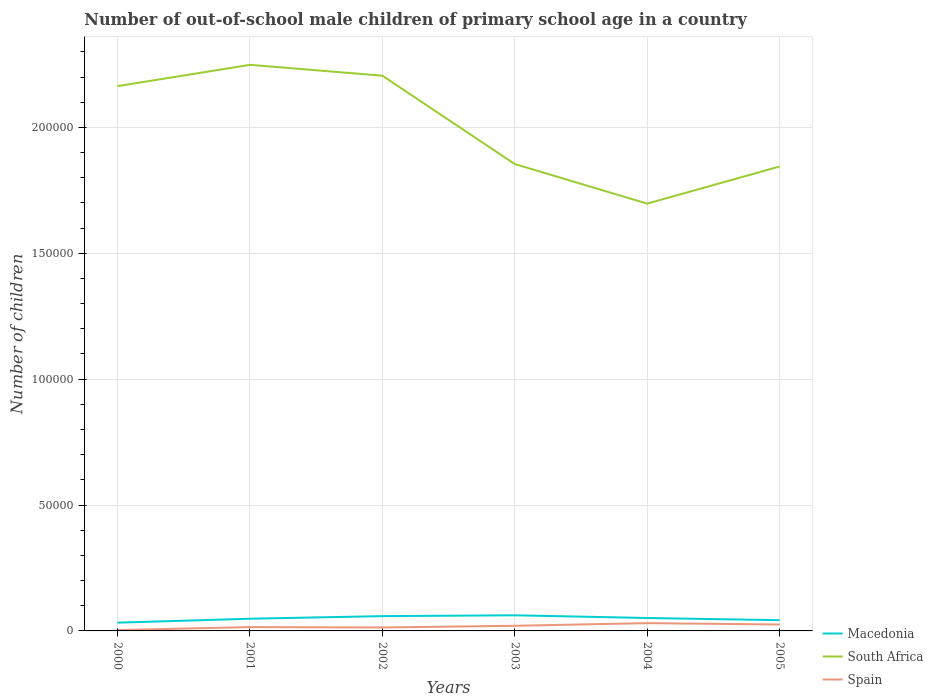Is the number of lines equal to the number of legend labels?
Your answer should be compact. Yes. Across all years, what is the maximum number of out-of-school male children in Spain?
Make the answer very short. 344. In which year was the number of out-of-school male children in Macedonia maximum?
Give a very brief answer. 2000. What is the total number of out-of-school male children in South Africa in the graph?
Give a very brief answer. 3.19e+04. What is the difference between the highest and the second highest number of out-of-school male children in Spain?
Give a very brief answer. 2748. What is the difference between the highest and the lowest number of out-of-school male children in South Africa?
Give a very brief answer. 3. Is the number of out-of-school male children in Macedonia strictly greater than the number of out-of-school male children in Spain over the years?
Give a very brief answer. No. What is the difference between two consecutive major ticks on the Y-axis?
Make the answer very short. 5.00e+04. Does the graph contain grids?
Give a very brief answer. Yes. How many legend labels are there?
Your answer should be compact. 3. How are the legend labels stacked?
Your answer should be very brief. Vertical. What is the title of the graph?
Offer a terse response. Number of out-of-school male children of primary school age in a country. What is the label or title of the Y-axis?
Provide a succinct answer. Number of children. What is the Number of children of Macedonia in 2000?
Keep it short and to the point. 3274. What is the Number of children of South Africa in 2000?
Keep it short and to the point. 2.16e+05. What is the Number of children of Spain in 2000?
Make the answer very short. 344. What is the Number of children in Macedonia in 2001?
Ensure brevity in your answer.  4844. What is the Number of children of South Africa in 2001?
Give a very brief answer. 2.25e+05. What is the Number of children of Spain in 2001?
Make the answer very short. 1514. What is the Number of children of Macedonia in 2002?
Give a very brief answer. 5878. What is the Number of children of South Africa in 2002?
Your answer should be compact. 2.21e+05. What is the Number of children in Spain in 2002?
Provide a short and direct response. 1368. What is the Number of children in Macedonia in 2003?
Keep it short and to the point. 6208. What is the Number of children of South Africa in 2003?
Offer a terse response. 1.85e+05. What is the Number of children in Spain in 2003?
Your response must be concise. 2044. What is the Number of children of Macedonia in 2004?
Offer a very short reply. 5133. What is the Number of children of South Africa in 2004?
Offer a very short reply. 1.70e+05. What is the Number of children of Spain in 2004?
Offer a very short reply. 3092. What is the Number of children in Macedonia in 2005?
Offer a terse response. 4262. What is the Number of children of South Africa in 2005?
Provide a succinct answer. 1.84e+05. What is the Number of children of Spain in 2005?
Your answer should be very brief. 2551. Across all years, what is the maximum Number of children of Macedonia?
Your answer should be very brief. 6208. Across all years, what is the maximum Number of children of South Africa?
Ensure brevity in your answer.  2.25e+05. Across all years, what is the maximum Number of children of Spain?
Provide a succinct answer. 3092. Across all years, what is the minimum Number of children of Macedonia?
Offer a very short reply. 3274. Across all years, what is the minimum Number of children in South Africa?
Provide a short and direct response. 1.70e+05. Across all years, what is the minimum Number of children in Spain?
Ensure brevity in your answer.  344. What is the total Number of children of Macedonia in the graph?
Provide a succinct answer. 2.96e+04. What is the total Number of children in South Africa in the graph?
Make the answer very short. 1.20e+06. What is the total Number of children of Spain in the graph?
Give a very brief answer. 1.09e+04. What is the difference between the Number of children in Macedonia in 2000 and that in 2001?
Offer a very short reply. -1570. What is the difference between the Number of children of South Africa in 2000 and that in 2001?
Ensure brevity in your answer.  -8460. What is the difference between the Number of children of Spain in 2000 and that in 2001?
Keep it short and to the point. -1170. What is the difference between the Number of children in Macedonia in 2000 and that in 2002?
Offer a terse response. -2604. What is the difference between the Number of children of South Africa in 2000 and that in 2002?
Provide a succinct answer. -4153. What is the difference between the Number of children in Spain in 2000 and that in 2002?
Your response must be concise. -1024. What is the difference between the Number of children of Macedonia in 2000 and that in 2003?
Ensure brevity in your answer.  -2934. What is the difference between the Number of children in South Africa in 2000 and that in 2003?
Offer a terse response. 3.09e+04. What is the difference between the Number of children in Spain in 2000 and that in 2003?
Offer a terse response. -1700. What is the difference between the Number of children of Macedonia in 2000 and that in 2004?
Provide a short and direct response. -1859. What is the difference between the Number of children of South Africa in 2000 and that in 2004?
Provide a succinct answer. 4.67e+04. What is the difference between the Number of children in Spain in 2000 and that in 2004?
Your answer should be compact. -2748. What is the difference between the Number of children of Macedonia in 2000 and that in 2005?
Make the answer very short. -988. What is the difference between the Number of children in South Africa in 2000 and that in 2005?
Keep it short and to the point. 3.19e+04. What is the difference between the Number of children of Spain in 2000 and that in 2005?
Your response must be concise. -2207. What is the difference between the Number of children of Macedonia in 2001 and that in 2002?
Your answer should be compact. -1034. What is the difference between the Number of children of South Africa in 2001 and that in 2002?
Give a very brief answer. 4307. What is the difference between the Number of children of Spain in 2001 and that in 2002?
Provide a short and direct response. 146. What is the difference between the Number of children of Macedonia in 2001 and that in 2003?
Keep it short and to the point. -1364. What is the difference between the Number of children in South Africa in 2001 and that in 2003?
Offer a terse response. 3.94e+04. What is the difference between the Number of children of Spain in 2001 and that in 2003?
Your answer should be very brief. -530. What is the difference between the Number of children of Macedonia in 2001 and that in 2004?
Offer a very short reply. -289. What is the difference between the Number of children in South Africa in 2001 and that in 2004?
Offer a very short reply. 5.51e+04. What is the difference between the Number of children in Spain in 2001 and that in 2004?
Offer a very short reply. -1578. What is the difference between the Number of children in Macedonia in 2001 and that in 2005?
Ensure brevity in your answer.  582. What is the difference between the Number of children in South Africa in 2001 and that in 2005?
Ensure brevity in your answer.  4.04e+04. What is the difference between the Number of children in Spain in 2001 and that in 2005?
Your answer should be very brief. -1037. What is the difference between the Number of children in Macedonia in 2002 and that in 2003?
Your answer should be very brief. -330. What is the difference between the Number of children in South Africa in 2002 and that in 2003?
Provide a succinct answer. 3.51e+04. What is the difference between the Number of children of Spain in 2002 and that in 2003?
Provide a succinct answer. -676. What is the difference between the Number of children of Macedonia in 2002 and that in 2004?
Give a very brief answer. 745. What is the difference between the Number of children in South Africa in 2002 and that in 2004?
Offer a very short reply. 5.08e+04. What is the difference between the Number of children in Spain in 2002 and that in 2004?
Your response must be concise. -1724. What is the difference between the Number of children of Macedonia in 2002 and that in 2005?
Provide a succinct answer. 1616. What is the difference between the Number of children in South Africa in 2002 and that in 2005?
Provide a short and direct response. 3.61e+04. What is the difference between the Number of children of Spain in 2002 and that in 2005?
Keep it short and to the point. -1183. What is the difference between the Number of children in Macedonia in 2003 and that in 2004?
Provide a short and direct response. 1075. What is the difference between the Number of children of South Africa in 2003 and that in 2004?
Your answer should be compact. 1.57e+04. What is the difference between the Number of children in Spain in 2003 and that in 2004?
Your answer should be compact. -1048. What is the difference between the Number of children in Macedonia in 2003 and that in 2005?
Provide a short and direct response. 1946. What is the difference between the Number of children in South Africa in 2003 and that in 2005?
Ensure brevity in your answer.  980. What is the difference between the Number of children of Spain in 2003 and that in 2005?
Keep it short and to the point. -507. What is the difference between the Number of children in Macedonia in 2004 and that in 2005?
Keep it short and to the point. 871. What is the difference between the Number of children in South Africa in 2004 and that in 2005?
Offer a very short reply. -1.47e+04. What is the difference between the Number of children of Spain in 2004 and that in 2005?
Make the answer very short. 541. What is the difference between the Number of children of Macedonia in 2000 and the Number of children of South Africa in 2001?
Offer a terse response. -2.22e+05. What is the difference between the Number of children of Macedonia in 2000 and the Number of children of Spain in 2001?
Provide a succinct answer. 1760. What is the difference between the Number of children in South Africa in 2000 and the Number of children in Spain in 2001?
Make the answer very short. 2.15e+05. What is the difference between the Number of children of Macedonia in 2000 and the Number of children of South Africa in 2002?
Your answer should be compact. -2.17e+05. What is the difference between the Number of children in Macedonia in 2000 and the Number of children in Spain in 2002?
Your response must be concise. 1906. What is the difference between the Number of children of South Africa in 2000 and the Number of children of Spain in 2002?
Provide a succinct answer. 2.15e+05. What is the difference between the Number of children in Macedonia in 2000 and the Number of children in South Africa in 2003?
Offer a terse response. -1.82e+05. What is the difference between the Number of children in Macedonia in 2000 and the Number of children in Spain in 2003?
Your response must be concise. 1230. What is the difference between the Number of children of South Africa in 2000 and the Number of children of Spain in 2003?
Offer a very short reply. 2.14e+05. What is the difference between the Number of children in Macedonia in 2000 and the Number of children in South Africa in 2004?
Give a very brief answer. -1.66e+05. What is the difference between the Number of children of Macedonia in 2000 and the Number of children of Spain in 2004?
Provide a succinct answer. 182. What is the difference between the Number of children in South Africa in 2000 and the Number of children in Spain in 2004?
Offer a terse response. 2.13e+05. What is the difference between the Number of children in Macedonia in 2000 and the Number of children in South Africa in 2005?
Make the answer very short. -1.81e+05. What is the difference between the Number of children in Macedonia in 2000 and the Number of children in Spain in 2005?
Offer a very short reply. 723. What is the difference between the Number of children in South Africa in 2000 and the Number of children in Spain in 2005?
Keep it short and to the point. 2.14e+05. What is the difference between the Number of children in Macedonia in 2001 and the Number of children in South Africa in 2002?
Give a very brief answer. -2.16e+05. What is the difference between the Number of children of Macedonia in 2001 and the Number of children of Spain in 2002?
Give a very brief answer. 3476. What is the difference between the Number of children of South Africa in 2001 and the Number of children of Spain in 2002?
Give a very brief answer. 2.23e+05. What is the difference between the Number of children in Macedonia in 2001 and the Number of children in South Africa in 2003?
Your answer should be compact. -1.81e+05. What is the difference between the Number of children in Macedonia in 2001 and the Number of children in Spain in 2003?
Your answer should be very brief. 2800. What is the difference between the Number of children of South Africa in 2001 and the Number of children of Spain in 2003?
Ensure brevity in your answer.  2.23e+05. What is the difference between the Number of children of Macedonia in 2001 and the Number of children of South Africa in 2004?
Your answer should be compact. -1.65e+05. What is the difference between the Number of children of Macedonia in 2001 and the Number of children of Spain in 2004?
Your answer should be compact. 1752. What is the difference between the Number of children in South Africa in 2001 and the Number of children in Spain in 2004?
Offer a terse response. 2.22e+05. What is the difference between the Number of children of Macedonia in 2001 and the Number of children of South Africa in 2005?
Make the answer very short. -1.80e+05. What is the difference between the Number of children of Macedonia in 2001 and the Number of children of Spain in 2005?
Offer a terse response. 2293. What is the difference between the Number of children of South Africa in 2001 and the Number of children of Spain in 2005?
Give a very brief answer. 2.22e+05. What is the difference between the Number of children in Macedonia in 2002 and the Number of children in South Africa in 2003?
Offer a terse response. -1.80e+05. What is the difference between the Number of children in Macedonia in 2002 and the Number of children in Spain in 2003?
Keep it short and to the point. 3834. What is the difference between the Number of children in South Africa in 2002 and the Number of children in Spain in 2003?
Make the answer very short. 2.19e+05. What is the difference between the Number of children in Macedonia in 2002 and the Number of children in South Africa in 2004?
Offer a very short reply. -1.64e+05. What is the difference between the Number of children of Macedonia in 2002 and the Number of children of Spain in 2004?
Offer a terse response. 2786. What is the difference between the Number of children of South Africa in 2002 and the Number of children of Spain in 2004?
Offer a very short reply. 2.17e+05. What is the difference between the Number of children of Macedonia in 2002 and the Number of children of South Africa in 2005?
Your answer should be compact. -1.79e+05. What is the difference between the Number of children in Macedonia in 2002 and the Number of children in Spain in 2005?
Offer a very short reply. 3327. What is the difference between the Number of children in South Africa in 2002 and the Number of children in Spain in 2005?
Provide a succinct answer. 2.18e+05. What is the difference between the Number of children of Macedonia in 2003 and the Number of children of South Africa in 2004?
Make the answer very short. -1.64e+05. What is the difference between the Number of children of Macedonia in 2003 and the Number of children of Spain in 2004?
Give a very brief answer. 3116. What is the difference between the Number of children of South Africa in 2003 and the Number of children of Spain in 2004?
Keep it short and to the point. 1.82e+05. What is the difference between the Number of children of Macedonia in 2003 and the Number of children of South Africa in 2005?
Provide a succinct answer. -1.78e+05. What is the difference between the Number of children in Macedonia in 2003 and the Number of children in Spain in 2005?
Your response must be concise. 3657. What is the difference between the Number of children of South Africa in 2003 and the Number of children of Spain in 2005?
Your response must be concise. 1.83e+05. What is the difference between the Number of children of Macedonia in 2004 and the Number of children of South Africa in 2005?
Offer a terse response. -1.79e+05. What is the difference between the Number of children of Macedonia in 2004 and the Number of children of Spain in 2005?
Provide a succinct answer. 2582. What is the difference between the Number of children of South Africa in 2004 and the Number of children of Spain in 2005?
Keep it short and to the point. 1.67e+05. What is the average Number of children of Macedonia per year?
Your answer should be very brief. 4933.17. What is the average Number of children in South Africa per year?
Your answer should be compact. 2.00e+05. What is the average Number of children in Spain per year?
Provide a short and direct response. 1818.83. In the year 2000, what is the difference between the Number of children in Macedonia and Number of children in South Africa?
Offer a terse response. -2.13e+05. In the year 2000, what is the difference between the Number of children of Macedonia and Number of children of Spain?
Offer a very short reply. 2930. In the year 2000, what is the difference between the Number of children of South Africa and Number of children of Spain?
Provide a short and direct response. 2.16e+05. In the year 2001, what is the difference between the Number of children in Macedonia and Number of children in South Africa?
Offer a very short reply. -2.20e+05. In the year 2001, what is the difference between the Number of children in Macedonia and Number of children in Spain?
Make the answer very short. 3330. In the year 2001, what is the difference between the Number of children in South Africa and Number of children in Spain?
Provide a short and direct response. 2.23e+05. In the year 2002, what is the difference between the Number of children in Macedonia and Number of children in South Africa?
Your answer should be compact. -2.15e+05. In the year 2002, what is the difference between the Number of children of Macedonia and Number of children of Spain?
Keep it short and to the point. 4510. In the year 2002, what is the difference between the Number of children of South Africa and Number of children of Spain?
Offer a very short reply. 2.19e+05. In the year 2003, what is the difference between the Number of children of Macedonia and Number of children of South Africa?
Ensure brevity in your answer.  -1.79e+05. In the year 2003, what is the difference between the Number of children in Macedonia and Number of children in Spain?
Keep it short and to the point. 4164. In the year 2003, what is the difference between the Number of children in South Africa and Number of children in Spain?
Make the answer very short. 1.83e+05. In the year 2004, what is the difference between the Number of children of Macedonia and Number of children of South Africa?
Your response must be concise. -1.65e+05. In the year 2004, what is the difference between the Number of children in Macedonia and Number of children in Spain?
Provide a succinct answer. 2041. In the year 2004, what is the difference between the Number of children in South Africa and Number of children in Spain?
Your answer should be compact. 1.67e+05. In the year 2005, what is the difference between the Number of children in Macedonia and Number of children in South Africa?
Keep it short and to the point. -1.80e+05. In the year 2005, what is the difference between the Number of children in Macedonia and Number of children in Spain?
Offer a terse response. 1711. In the year 2005, what is the difference between the Number of children in South Africa and Number of children in Spain?
Provide a short and direct response. 1.82e+05. What is the ratio of the Number of children in Macedonia in 2000 to that in 2001?
Your response must be concise. 0.68. What is the ratio of the Number of children of South Africa in 2000 to that in 2001?
Ensure brevity in your answer.  0.96. What is the ratio of the Number of children of Spain in 2000 to that in 2001?
Give a very brief answer. 0.23. What is the ratio of the Number of children in Macedonia in 2000 to that in 2002?
Your response must be concise. 0.56. What is the ratio of the Number of children of South Africa in 2000 to that in 2002?
Make the answer very short. 0.98. What is the ratio of the Number of children of Spain in 2000 to that in 2002?
Your answer should be compact. 0.25. What is the ratio of the Number of children in Macedonia in 2000 to that in 2003?
Ensure brevity in your answer.  0.53. What is the ratio of the Number of children of South Africa in 2000 to that in 2003?
Keep it short and to the point. 1.17. What is the ratio of the Number of children in Spain in 2000 to that in 2003?
Your answer should be very brief. 0.17. What is the ratio of the Number of children of Macedonia in 2000 to that in 2004?
Make the answer very short. 0.64. What is the ratio of the Number of children in South Africa in 2000 to that in 2004?
Your answer should be compact. 1.27. What is the ratio of the Number of children in Spain in 2000 to that in 2004?
Offer a very short reply. 0.11. What is the ratio of the Number of children in Macedonia in 2000 to that in 2005?
Provide a short and direct response. 0.77. What is the ratio of the Number of children in South Africa in 2000 to that in 2005?
Provide a short and direct response. 1.17. What is the ratio of the Number of children in Spain in 2000 to that in 2005?
Ensure brevity in your answer.  0.13. What is the ratio of the Number of children of Macedonia in 2001 to that in 2002?
Make the answer very short. 0.82. What is the ratio of the Number of children of South Africa in 2001 to that in 2002?
Make the answer very short. 1.02. What is the ratio of the Number of children in Spain in 2001 to that in 2002?
Your answer should be compact. 1.11. What is the ratio of the Number of children in Macedonia in 2001 to that in 2003?
Keep it short and to the point. 0.78. What is the ratio of the Number of children of South Africa in 2001 to that in 2003?
Your answer should be very brief. 1.21. What is the ratio of the Number of children of Spain in 2001 to that in 2003?
Make the answer very short. 0.74. What is the ratio of the Number of children in Macedonia in 2001 to that in 2004?
Give a very brief answer. 0.94. What is the ratio of the Number of children in South Africa in 2001 to that in 2004?
Offer a very short reply. 1.32. What is the ratio of the Number of children of Spain in 2001 to that in 2004?
Your response must be concise. 0.49. What is the ratio of the Number of children in Macedonia in 2001 to that in 2005?
Your response must be concise. 1.14. What is the ratio of the Number of children of South Africa in 2001 to that in 2005?
Your answer should be very brief. 1.22. What is the ratio of the Number of children in Spain in 2001 to that in 2005?
Ensure brevity in your answer.  0.59. What is the ratio of the Number of children in Macedonia in 2002 to that in 2003?
Your answer should be compact. 0.95. What is the ratio of the Number of children in South Africa in 2002 to that in 2003?
Provide a short and direct response. 1.19. What is the ratio of the Number of children of Spain in 2002 to that in 2003?
Your response must be concise. 0.67. What is the ratio of the Number of children in Macedonia in 2002 to that in 2004?
Give a very brief answer. 1.15. What is the ratio of the Number of children in South Africa in 2002 to that in 2004?
Provide a succinct answer. 1.3. What is the ratio of the Number of children of Spain in 2002 to that in 2004?
Your response must be concise. 0.44. What is the ratio of the Number of children in Macedonia in 2002 to that in 2005?
Keep it short and to the point. 1.38. What is the ratio of the Number of children of South Africa in 2002 to that in 2005?
Give a very brief answer. 1.2. What is the ratio of the Number of children in Spain in 2002 to that in 2005?
Make the answer very short. 0.54. What is the ratio of the Number of children in Macedonia in 2003 to that in 2004?
Provide a succinct answer. 1.21. What is the ratio of the Number of children of South Africa in 2003 to that in 2004?
Offer a terse response. 1.09. What is the ratio of the Number of children in Spain in 2003 to that in 2004?
Your response must be concise. 0.66. What is the ratio of the Number of children in Macedonia in 2003 to that in 2005?
Your response must be concise. 1.46. What is the ratio of the Number of children of Spain in 2003 to that in 2005?
Provide a succinct answer. 0.8. What is the ratio of the Number of children in Macedonia in 2004 to that in 2005?
Offer a very short reply. 1.2. What is the ratio of the Number of children of South Africa in 2004 to that in 2005?
Your answer should be very brief. 0.92. What is the ratio of the Number of children of Spain in 2004 to that in 2005?
Make the answer very short. 1.21. What is the difference between the highest and the second highest Number of children in Macedonia?
Provide a short and direct response. 330. What is the difference between the highest and the second highest Number of children of South Africa?
Offer a very short reply. 4307. What is the difference between the highest and the second highest Number of children in Spain?
Offer a terse response. 541. What is the difference between the highest and the lowest Number of children in Macedonia?
Make the answer very short. 2934. What is the difference between the highest and the lowest Number of children of South Africa?
Your answer should be compact. 5.51e+04. What is the difference between the highest and the lowest Number of children in Spain?
Offer a very short reply. 2748. 